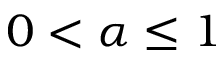Convert formula to latex. <formula><loc_0><loc_0><loc_500><loc_500>0 < \alpha \leq 1</formula> 